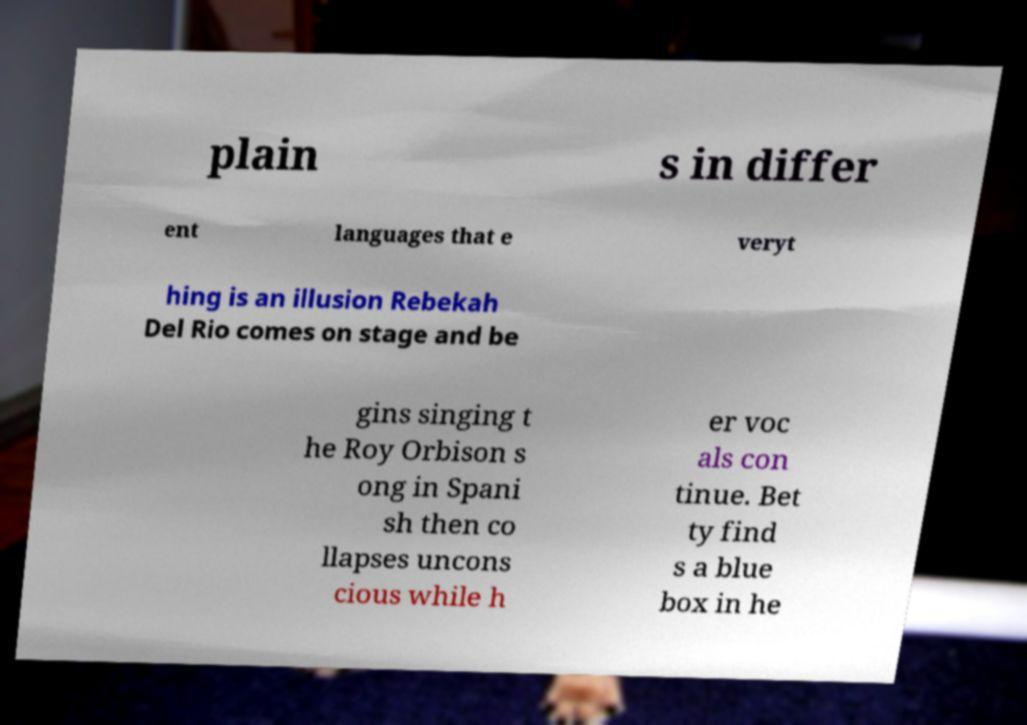There's text embedded in this image that I need extracted. Can you transcribe it verbatim? plain s in differ ent languages that e veryt hing is an illusion Rebekah Del Rio comes on stage and be gins singing t he Roy Orbison s ong in Spani sh then co llapses uncons cious while h er voc als con tinue. Bet ty find s a blue box in he 